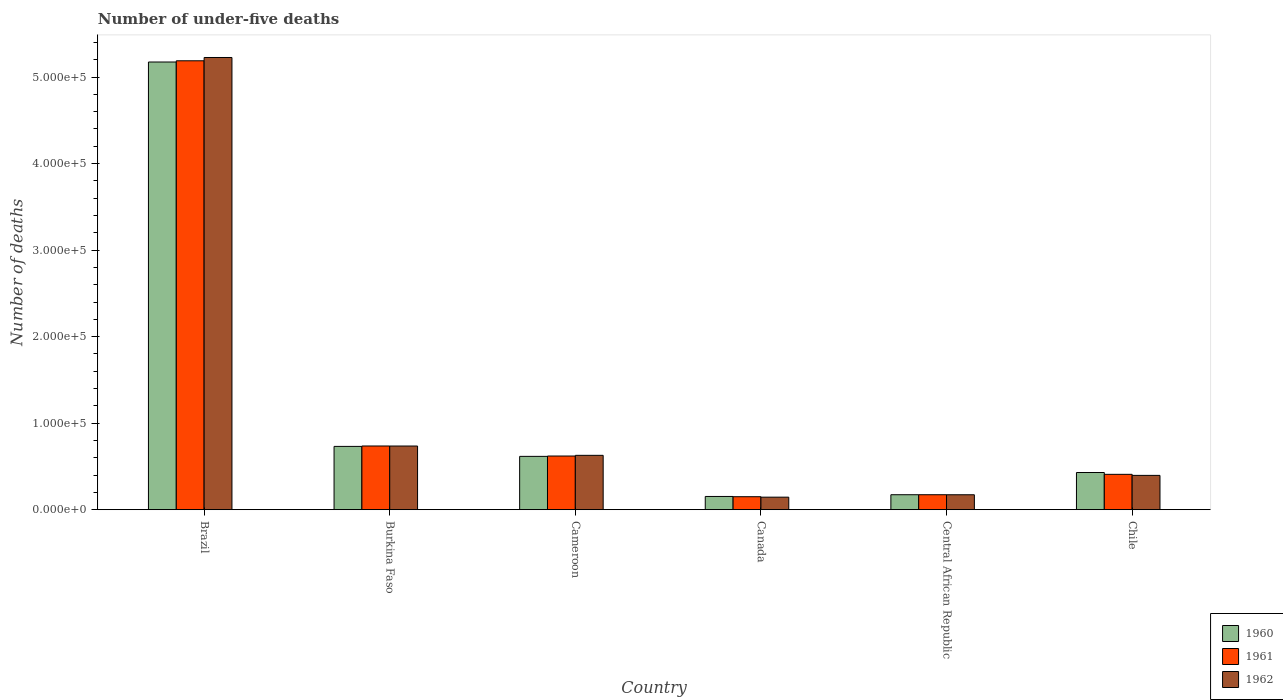How many different coloured bars are there?
Your answer should be compact. 3. How many groups of bars are there?
Provide a succinct answer. 6. Are the number of bars per tick equal to the number of legend labels?
Offer a terse response. Yes. Are the number of bars on each tick of the X-axis equal?
Keep it short and to the point. Yes. How many bars are there on the 6th tick from the left?
Offer a terse response. 3. What is the label of the 5th group of bars from the left?
Ensure brevity in your answer.  Central African Republic. In how many cases, is the number of bars for a given country not equal to the number of legend labels?
Your answer should be compact. 0. What is the number of under-five deaths in 1962 in Burkina Faso?
Give a very brief answer. 7.36e+04. Across all countries, what is the maximum number of under-five deaths in 1960?
Provide a short and direct response. 5.17e+05. Across all countries, what is the minimum number of under-five deaths in 1962?
Give a very brief answer. 1.45e+04. In which country was the number of under-five deaths in 1961 maximum?
Your answer should be very brief. Brazil. What is the total number of under-five deaths in 1961 in the graph?
Your response must be concise. 7.28e+05. What is the difference between the number of under-five deaths in 1961 in Canada and that in Central African Republic?
Offer a very short reply. -2304. What is the difference between the number of under-five deaths in 1962 in Brazil and the number of under-five deaths in 1960 in Cameroon?
Your answer should be compact. 4.61e+05. What is the average number of under-five deaths in 1962 per country?
Your response must be concise. 1.22e+05. What is the difference between the number of under-five deaths of/in 1960 and number of under-five deaths of/in 1961 in Central African Republic?
Your response must be concise. -1. In how many countries, is the number of under-five deaths in 1961 greater than 360000?
Your response must be concise. 1. What is the ratio of the number of under-five deaths in 1960 in Brazil to that in Central African Republic?
Ensure brevity in your answer.  29.9. What is the difference between the highest and the second highest number of under-five deaths in 1962?
Make the answer very short. -4.60e+05. What is the difference between the highest and the lowest number of under-five deaths in 1960?
Provide a short and direct response. 5.02e+05. In how many countries, is the number of under-five deaths in 1960 greater than the average number of under-five deaths in 1960 taken over all countries?
Your answer should be compact. 1. Is the sum of the number of under-five deaths in 1962 in Burkina Faso and Cameroon greater than the maximum number of under-five deaths in 1961 across all countries?
Your answer should be very brief. No. What does the 2nd bar from the left in Canada represents?
Offer a terse response. 1961. What does the 1st bar from the right in Cameroon represents?
Your response must be concise. 1962. Is it the case that in every country, the sum of the number of under-five deaths in 1961 and number of under-five deaths in 1962 is greater than the number of under-five deaths in 1960?
Make the answer very short. Yes. How many bars are there?
Your answer should be compact. 18. Are all the bars in the graph horizontal?
Offer a terse response. No. How many legend labels are there?
Your answer should be compact. 3. How are the legend labels stacked?
Ensure brevity in your answer.  Vertical. What is the title of the graph?
Offer a very short reply. Number of under-five deaths. What is the label or title of the Y-axis?
Your answer should be very brief. Number of deaths. What is the Number of deaths in 1960 in Brazil?
Your answer should be very brief. 5.17e+05. What is the Number of deaths in 1961 in Brazil?
Provide a short and direct response. 5.19e+05. What is the Number of deaths in 1962 in Brazil?
Your response must be concise. 5.23e+05. What is the Number of deaths of 1960 in Burkina Faso?
Ensure brevity in your answer.  7.32e+04. What is the Number of deaths in 1961 in Burkina Faso?
Make the answer very short. 7.36e+04. What is the Number of deaths of 1962 in Burkina Faso?
Keep it short and to the point. 7.36e+04. What is the Number of deaths in 1960 in Cameroon?
Give a very brief answer. 6.16e+04. What is the Number of deaths in 1961 in Cameroon?
Provide a short and direct response. 6.20e+04. What is the Number of deaths in 1962 in Cameroon?
Give a very brief answer. 6.28e+04. What is the Number of deaths of 1960 in Canada?
Keep it short and to the point. 1.53e+04. What is the Number of deaths in 1961 in Canada?
Provide a succinct answer. 1.50e+04. What is the Number of deaths of 1962 in Canada?
Keep it short and to the point. 1.45e+04. What is the Number of deaths of 1960 in Central African Republic?
Your answer should be very brief. 1.73e+04. What is the Number of deaths in 1961 in Central African Republic?
Offer a very short reply. 1.73e+04. What is the Number of deaths in 1962 in Central African Republic?
Your answer should be compact. 1.73e+04. What is the Number of deaths of 1960 in Chile?
Provide a succinct answer. 4.30e+04. What is the Number of deaths of 1961 in Chile?
Offer a terse response. 4.09e+04. What is the Number of deaths in 1962 in Chile?
Offer a terse response. 3.97e+04. Across all countries, what is the maximum Number of deaths in 1960?
Provide a succinct answer. 5.17e+05. Across all countries, what is the maximum Number of deaths of 1961?
Offer a terse response. 5.19e+05. Across all countries, what is the maximum Number of deaths in 1962?
Give a very brief answer. 5.23e+05. Across all countries, what is the minimum Number of deaths in 1960?
Your response must be concise. 1.53e+04. Across all countries, what is the minimum Number of deaths in 1961?
Provide a succinct answer. 1.50e+04. Across all countries, what is the minimum Number of deaths of 1962?
Your response must be concise. 1.45e+04. What is the total Number of deaths in 1960 in the graph?
Your response must be concise. 7.28e+05. What is the total Number of deaths in 1961 in the graph?
Your response must be concise. 7.28e+05. What is the total Number of deaths of 1962 in the graph?
Your answer should be very brief. 7.30e+05. What is the difference between the Number of deaths of 1960 in Brazil and that in Burkina Faso?
Keep it short and to the point. 4.44e+05. What is the difference between the Number of deaths of 1961 in Brazil and that in Burkina Faso?
Provide a succinct answer. 4.45e+05. What is the difference between the Number of deaths in 1962 in Brazil and that in Burkina Faso?
Make the answer very short. 4.49e+05. What is the difference between the Number of deaths of 1960 in Brazil and that in Cameroon?
Provide a short and direct response. 4.56e+05. What is the difference between the Number of deaths in 1961 in Brazil and that in Cameroon?
Your answer should be very brief. 4.57e+05. What is the difference between the Number of deaths of 1962 in Brazil and that in Cameroon?
Your answer should be very brief. 4.60e+05. What is the difference between the Number of deaths of 1960 in Brazil and that in Canada?
Ensure brevity in your answer.  5.02e+05. What is the difference between the Number of deaths of 1961 in Brazil and that in Canada?
Ensure brevity in your answer.  5.04e+05. What is the difference between the Number of deaths of 1962 in Brazil and that in Canada?
Provide a short and direct response. 5.08e+05. What is the difference between the Number of deaths in 1960 in Brazil and that in Central African Republic?
Provide a succinct answer. 5.00e+05. What is the difference between the Number of deaths of 1961 in Brazil and that in Central African Republic?
Your answer should be compact. 5.02e+05. What is the difference between the Number of deaths in 1962 in Brazil and that in Central African Republic?
Make the answer very short. 5.05e+05. What is the difference between the Number of deaths of 1960 in Brazil and that in Chile?
Your answer should be compact. 4.74e+05. What is the difference between the Number of deaths of 1961 in Brazil and that in Chile?
Your response must be concise. 4.78e+05. What is the difference between the Number of deaths in 1962 in Brazil and that in Chile?
Your answer should be compact. 4.83e+05. What is the difference between the Number of deaths in 1960 in Burkina Faso and that in Cameroon?
Keep it short and to the point. 1.15e+04. What is the difference between the Number of deaths in 1961 in Burkina Faso and that in Cameroon?
Your response must be concise. 1.16e+04. What is the difference between the Number of deaths in 1962 in Burkina Faso and that in Cameroon?
Make the answer very short. 1.08e+04. What is the difference between the Number of deaths in 1960 in Burkina Faso and that in Canada?
Make the answer very short. 5.79e+04. What is the difference between the Number of deaths in 1961 in Burkina Faso and that in Canada?
Your answer should be compact. 5.86e+04. What is the difference between the Number of deaths in 1962 in Burkina Faso and that in Canada?
Your response must be concise. 5.91e+04. What is the difference between the Number of deaths in 1960 in Burkina Faso and that in Central African Republic?
Offer a terse response. 5.59e+04. What is the difference between the Number of deaths in 1961 in Burkina Faso and that in Central African Republic?
Offer a terse response. 5.63e+04. What is the difference between the Number of deaths of 1962 in Burkina Faso and that in Central African Republic?
Your answer should be compact. 5.63e+04. What is the difference between the Number of deaths of 1960 in Burkina Faso and that in Chile?
Your answer should be compact. 3.02e+04. What is the difference between the Number of deaths of 1961 in Burkina Faso and that in Chile?
Give a very brief answer. 3.28e+04. What is the difference between the Number of deaths in 1962 in Burkina Faso and that in Chile?
Give a very brief answer. 3.39e+04. What is the difference between the Number of deaths in 1960 in Cameroon and that in Canada?
Make the answer very short. 4.63e+04. What is the difference between the Number of deaths of 1961 in Cameroon and that in Canada?
Offer a terse response. 4.70e+04. What is the difference between the Number of deaths in 1962 in Cameroon and that in Canada?
Your answer should be very brief. 4.83e+04. What is the difference between the Number of deaths in 1960 in Cameroon and that in Central African Republic?
Provide a succinct answer. 4.43e+04. What is the difference between the Number of deaths in 1961 in Cameroon and that in Central African Republic?
Make the answer very short. 4.47e+04. What is the difference between the Number of deaths in 1962 in Cameroon and that in Central African Republic?
Keep it short and to the point. 4.56e+04. What is the difference between the Number of deaths of 1960 in Cameroon and that in Chile?
Your response must be concise. 1.87e+04. What is the difference between the Number of deaths of 1961 in Cameroon and that in Chile?
Make the answer very short. 2.12e+04. What is the difference between the Number of deaths of 1962 in Cameroon and that in Chile?
Offer a terse response. 2.32e+04. What is the difference between the Number of deaths in 1960 in Canada and that in Central African Republic?
Keep it short and to the point. -2000. What is the difference between the Number of deaths of 1961 in Canada and that in Central African Republic?
Your answer should be compact. -2304. What is the difference between the Number of deaths of 1962 in Canada and that in Central African Republic?
Make the answer very short. -2788. What is the difference between the Number of deaths in 1960 in Canada and that in Chile?
Provide a short and direct response. -2.77e+04. What is the difference between the Number of deaths of 1961 in Canada and that in Chile?
Give a very brief answer. -2.59e+04. What is the difference between the Number of deaths of 1962 in Canada and that in Chile?
Your answer should be compact. -2.52e+04. What is the difference between the Number of deaths of 1960 in Central African Republic and that in Chile?
Provide a short and direct response. -2.57e+04. What is the difference between the Number of deaths in 1961 in Central African Republic and that in Chile?
Your answer should be compact. -2.36e+04. What is the difference between the Number of deaths of 1962 in Central African Republic and that in Chile?
Provide a succinct answer. -2.24e+04. What is the difference between the Number of deaths of 1960 in Brazil and the Number of deaths of 1961 in Burkina Faso?
Ensure brevity in your answer.  4.44e+05. What is the difference between the Number of deaths in 1960 in Brazil and the Number of deaths in 1962 in Burkina Faso?
Offer a terse response. 4.44e+05. What is the difference between the Number of deaths of 1961 in Brazil and the Number of deaths of 1962 in Burkina Faso?
Offer a terse response. 4.45e+05. What is the difference between the Number of deaths in 1960 in Brazil and the Number of deaths in 1961 in Cameroon?
Offer a terse response. 4.55e+05. What is the difference between the Number of deaths in 1960 in Brazil and the Number of deaths in 1962 in Cameroon?
Ensure brevity in your answer.  4.55e+05. What is the difference between the Number of deaths of 1961 in Brazil and the Number of deaths of 1962 in Cameroon?
Keep it short and to the point. 4.56e+05. What is the difference between the Number of deaths of 1960 in Brazil and the Number of deaths of 1961 in Canada?
Keep it short and to the point. 5.02e+05. What is the difference between the Number of deaths in 1960 in Brazil and the Number of deaths in 1962 in Canada?
Your response must be concise. 5.03e+05. What is the difference between the Number of deaths in 1961 in Brazil and the Number of deaths in 1962 in Canada?
Provide a short and direct response. 5.04e+05. What is the difference between the Number of deaths of 1960 in Brazil and the Number of deaths of 1961 in Central African Republic?
Your answer should be compact. 5.00e+05. What is the difference between the Number of deaths in 1960 in Brazil and the Number of deaths in 1962 in Central African Republic?
Provide a succinct answer. 5.00e+05. What is the difference between the Number of deaths in 1961 in Brazil and the Number of deaths in 1962 in Central African Republic?
Provide a succinct answer. 5.02e+05. What is the difference between the Number of deaths in 1960 in Brazil and the Number of deaths in 1961 in Chile?
Ensure brevity in your answer.  4.77e+05. What is the difference between the Number of deaths of 1960 in Brazil and the Number of deaths of 1962 in Chile?
Your answer should be compact. 4.78e+05. What is the difference between the Number of deaths of 1961 in Brazil and the Number of deaths of 1962 in Chile?
Your response must be concise. 4.79e+05. What is the difference between the Number of deaths in 1960 in Burkina Faso and the Number of deaths in 1961 in Cameroon?
Your answer should be compact. 1.11e+04. What is the difference between the Number of deaths of 1960 in Burkina Faso and the Number of deaths of 1962 in Cameroon?
Offer a very short reply. 1.03e+04. What is the difference between the Number of deaths in 1961 in Burkina Faso and the Number of deaths in 1962 in Cameroon?
Keep it short and to the point. 1.08e+04. What is the difference between the Number of deaths of 1960 in Burkina Faso and the Number of deaths of 1961 in Canada?
Your answer should be very brief. 5.82e+04. What is the difference between the Number of deaths of 1960 in Burkina Faso and the Number of deaths of 1962 in Canada?
Give a very brief answer. 5.87e+04. What is the difference between the Number of deaths of 1961 in Burkina Faso and the Number of deaths of 1962 in Canada?
Make the answer very short. 5.91e+04. What is the difference between the Number of deaths in 1960 in Burkina Faso and the Number of deaths in 1961 in Central African Republic?
Your answer should be very brief. 5.59e+04. What is the difference between the Number of deaths in 1960 in Burkina Faso and the Number of deaths in 1962 in Central African Republic?
Offer a terse response. 5.59e+04. What is the difference between the Number of deaths in 1961 in Burkina Faso and the Number of deaths in 1962 in Central African Republic?
Provide a short and direct response. 5.64e+04. What is the difference between the Number of deaths of 1960 in Burkina Faso and the Number of deaths of 1961 in Chile?
Offer a terse response. 3.23e+04. What is the difference between the Number of deaths in 1960 in Burkina Faso and the Number of deaths in 1962 in Chile?
Give a very brief answer. 3.35e+04. What is the difference between the Number of deaths of 1961 in Burkina Faso and the Number of deaths of 1962 in Chile?
Offer a terse response. 3.40e+04. What is the difference between the Number of deaths of 1960 in Cameroon and the Number of deaths of 1961 in Canada?
Keep it short and to the point. 4.66e+04. What is the difference between the Number of deaths in 1960 in Cameroon and the Number of deaths in 1962 in Canada?
Make the answer very short. 4.72e+04. What is the difference between the Number of deaths in 1961 in Cameroon and the Number of deaths in 1962 in Canada?
Give a very brief answer. 4.76e+04. What is the difference between the Number of deaths in 1960 in Cameroon and the Number of deaths in 1961 in Central African Republic?
Your answer should be very brief. 4.43e+04. What is the difference between the Number of deaths of 1960 in Cameroon and the Number of deaths of 1962 in Central African Republic?
Provide a short and direct response. 4.44e+04. What is the difference between the Number of deaths in 1961 in Cameroon and the Number of deaths in 1962 in Central African Republic?
Keep it short and to the point. 4.48e+04. What is the difference between the Number of deaths of 1960 in Cameroon and the Number of deaths of 1961 in Chile?
Give a very brief answer. 2.08e+04. What is the difference between the Number of deaths of 1960 in Cameroon and the Number of deaths of 1962 in Chile?
Make the answer very short. 2.20e+04. What is the difference between the Number of deaths in 1961 in Cameroon and the Number of deaths in 1962 in Chile?
Offer a very short reply. 2.24e+04. What is the difference between the Number of deaths in 1960 in Canada and the Number of deaths in 1961 in Central African Republic?
Your answer should be very brief. -2001. What is the difference between the Number of deaths of 1960 in Canada and the Number of deaths of 1962 in Central African Republic?
Your response must be concise. -1968. What is the difference between the Number of deaths of 1961 in Canada and the Number of deaths of 1962 in Central African Republic?
Your answer should be compact. -2271. What is the difference between the Number of deaths of 1960 in Canada and the Number of deaths of 1961 in Chile?
Provide a short and direct response. -2.56e+04. What is the difference between the Number of deaths of 1960 in Canada and the Number of deaths of 1962 in Chile?
Offer a very short reply. -2.44e+04. What is the difference between the Number of deaths of 1961 in Canada and the Number of deaths of 1962 in Chile?
Your response must be concise. -2.47e+04. What is the difference between the Number of deaths in 1960 in Central African Republic and the Number of deaths in 1961 in Chile?
Offer a terse response. -2.36e+04. What is the difference between the Number of deaths in 1960 in Central African Republic and the Number of deaths in 1962 in Chile?
Your answer should be very brief. -2.24e+04. What is the difference between the Number of deaths in 1961 in Central African Republic and the Number of deaths in 1962 in Chile?
Give a very brief answer. -2.23e+04. What is the average Number of deaths in 1960 per country?
Provide a succinct answer. 1.21e+05. What is the average Number of deaths of 1961 per country?
Your response must be concise. 1.21e+05. What is the average Number of deaths in 1962 per country?
Offer a very short reply. 1.22e+05. What is the difference between the Number of deaths in 1960 and Number of deaths in 1961 in Brazil?
Provide a short and direct response. -1424. What is the difference between the Number of deaths of 1960 and Number of deaths of 1962 in Brazil?
Offer a very short reply. -5233. What is the difference between the Number of deaths in 1961 and Number of deaths in 1962 in Brazil?
Make the answer very short. -3809. What is the difference between the Number of deaths of 1960 and Number of deaths of 1961 in Burkina Faso?
Your answer should be compact. -465. What is the difference between the Number of deaths of 1960 and Number of deaths of 1962 in Burkina Faso?
Provide a short and direct response. -423. What is the difference between the Number of deaths of 1961 and Number of deaths of 1962 in Burkina Faso?
Give a very brief answer. 42. What is the difference between the Number of deaths in 1960 and Number of deaths in 1961 in Cameroon?
Make the answer very short. -396. What is the difference between the Number of deaths of 1960 and Number of deaths of 1962 in Cameroon?
Your answer should be very brief. -1194. What is the difference between the Number of deaths of 1961 and Number of deaths of 1962 in Cameroon?
Offer a terse response. -798. What is the difference between the Number of deaths of 1960 and Number of deaths of 1961 in Canada?
Your response must be concise. 303. What is the difference between the Number of deaths of 1960 and Number of deaths of 1962 in Canada?
Your answer should be compact. 820. What is the difference between the Number of deaths in 1961 and Number of deaths in 1962 in Canada?
Keep it short and to the point. 517. What is the difference between the Number of deaths of 1960 and Number of deaths of 1961 in Chile?
Offer a very short reply. 2108. What is the difference between the Number of deaths in 1960 and Number of deaths in 1962 in Chile?
Offer a very short reply. 3325. What is the difference between the Number of deaths in 1961 and Number of deaths in 1962 in Chile?
Keep it short and to the point. 1217. What is the ratio of the Number of deaths of 1960 in Brazil to that in Burkina Faso?
Keep it short and to the point. 7.07. What is the ratio of the Number of deaths of 1961 in Brazil to that in Burkina Faso?
Your answer should be compact. 7.05. What is the ratio of the Number of deaths in 1962 in Brazil to that in Burkina Faso?
Your answer should be very brief. 7.1. What is the ratio of the Number of deaths in 1960 in Brazil to that in Cameroon?
Provide a short and direct response. 8.39. What is the ratio of the Number of deaths in 1961 in Brazil to that in Cameroon?
Offer a terse response. 8.36. What is the ratio of the Number of deaths of 1962 in Brazil to that in Cameroon?
Offer a very short reply. 8.32. What is the ratio of the Number of deaths of 1960 in Brazil to that in Canada?
Your answer should be compact. 33.81. What is the ratio of the Number of deaths of 1961 in Brazil to that in Canada?
Offer a very short reply. 34.58. What is the ratio of the Number of deaths of 1962 in Brazil to that in Canada?
Make the answer very short. 36.08. What is the ratio of the Number of deaths in 1960 in Brazil to that in Central African Republic?
Your response must be concise. 29.9. What is the ratio of the Number of deaths in 1961 in Brazil to that in Central African Republic?
Ensure brevity in your answer.  29.98. What is the ratio of the Number of deaths in 1962 in Brazil to that in Central African Republic?
Provide a succinct answer. 30.26. What is the ratio of the Number of deaths in 1960 in Brazil to that in Chile?
Your answer should be very brief. 12.04. What is the ratio of the Number of deaths in 1961 in Brazil to that in Chile?
Your answer should be compact. 12.69. What is the ratio of the Number of deaths in 1962 in Brazil to that in Chile?
Your answer should be compact. 13.18. What is the ratio of the Number of deaths of 1960 in Burkina Faso to that in Cameroon?
Give a very brief answer. 1.19. What is the ratio of the Number of deaths in 1961 in Burkina Faso to that in Cameroon?
Provide a succinct answer. 1.19. What is the ratio of the Number of deaths of 1962 in Burkina Faso to that in Cameroon?
Make the answer very short. 1.17. What is the ratio of the Number of deaths in 1960 in Burkina Faso to that in Canada?
Your answer should be compact. 4.78. What is the ratio of the Number of deaths of 1961 in Burkina Faso to that in Canada?
Offer a very short reply. 4.91. What is the ratio of the Number of deaths in 1962 in Burkina Faso to that in Canada?
Provide a succinct answer. 5.08. What is the ratio of the Number of deaths in 1960 in Burkina Faso to that in Central African Republic?
Provide a succinct answer. 4.23. What is the ratio of the Number of deaths of 1961 in Burkina Faso to that in Central African Republic?
Offer a terse response. 4.25. What is the ratio of the Number of deaths in 1962 in Burkina Faso to that in Central African Republic?
Offer a terse response. 4.26. What is the ratio of the Number of deaths in 1960 in Burkina Faso to that in Chile?
Your answer should be compact. 1.7. What is the ratio of the Number of deaths in 1961 in Burkina Faso to that in Chile?
Your answer should be very brief. 1.8. What is the ratio of the Number of deaths of 1962 in Burkina Faso to that in Chile?
Provide a short and direct response. 1.86. What is the ratio of the Number of deaths of 1960 in Cameroon to that in Canada?
Your response must be concise. 4.03. What is the ratio of the Number of deaths in 1961 in Cameroon to that in Canada?
Make the answer very short. 4.14. What is the ratio of the Number of deaths of 1962 in Cameroon to that in Canada?
Provide a short and direct response. 4.34. What is the ratio of the Number of deaths in 1960 in Cameroon to that in Central African Republic?
Give a very brief answer. 3.56. What is the ratio of the Number of deaths in 1961 in Cameroon to that in Central African Republic?
Your answer should be compact. 3.58. What is the ratio of the Number of deaths in 1962 in Cameroon to that in Central African Republic?
Keep it short and to the point. 3.64. What is the ratio of the Number of deaths of 1960 in Cameroon to that in Chile?
Keep it short and to the point. 1.43. What is the ratio of the Number of deaths of 1961 in Cameroon to that in Chile?
Give a very brief answer. 1.52. What is the ratio of the Number of deaths in 1962 in Cameroon to that in Chile?
Keep it short and to the point. 1.58. What is the ratio of the Number of deaths of 1960 in Canada to that in Central African Republic?
Your response must be concise. 0.88. What is the ratio of the Number of deaths of 1961 in Canada to that in Central African Republic?
Your answer should be compact. 0.87. What is the ratio of the Number of deaths in 1962 in Canada to that in Central African Republic?
Your answer should be very brief. 0.84. What is the ratio of the Number of deaths of 1960 in Canada to that in Chile?
Your response must be concise. 0.36. What is the ratio of the Number of deaths in 1961 in Canada to that in Chile?
Offer a terse response. 0.37. What is the ratio of the Number of deaths in 1962 in Canada to that in Chile?
Make the answer very short. 0.37. What is the ratio of the Number of deaths in 1960 in Central African Republic to that in Chile?
Provide a short and direct response. 0.4. What is the ratio of the Number of deaths in 1961 in Central African Republic to that in Chile?
Your answer should be compact. 0.42. What is the ratio of the Number of deaths in 1962 in Central African Republic to that in Chile?
Offer a very short reply. 0.44. What is the difference between the highest and the second highest Number of deaths in 1960?
Provide a short and direct response. 4.44e+05. What is the difference between the highest and the second highest Number of deaths of 1961?
Offer a terse response. 4.45e+05. What is the difference between the highest and the second highest Number of deaths in 1962?
Provide a succinct answer. 4.49e+05. What is the difference between the highest and the lowest Number of deaths of 1960?
Your answer should be compact. 5.02e+05. What is the difference between the highest and the lowest Number of deaths in 1961?
Your answer should be compact. 5.04e+05. What is the difference between the highest and the lowest Number of deaths in 1962?
Offer a terse response. 5.08e+05. 